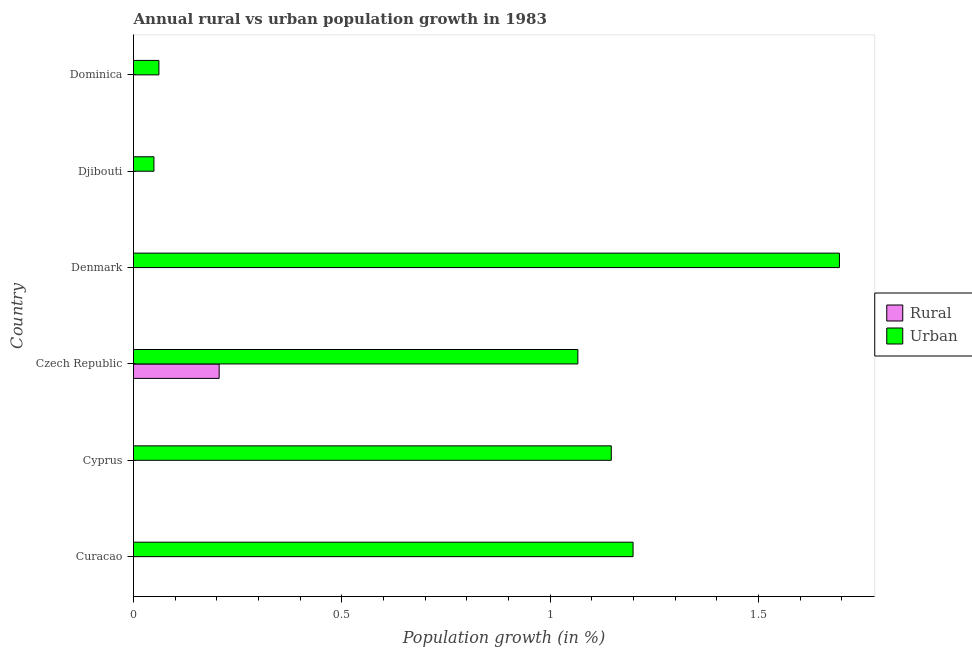Are the number of bars per tick equal to the number of legend labels?
Keep it short and to the point. No. What is the label of the 1st group of bars from the top?
Give a very brief answer. Dominica. In how many cases, is the number of bars for a given country not equal to the number of legend labels?
Your answer should be compact. 5. What is the urban population growth in Denmark?
Provide a succinct answer. 1.69. Across all countries, what is the maximum rural population growth?
Provide a short and direct response. 0.21. Across all countries, what is the minimum urban population growth?
Give a very brief answer. 0.05. What is the total rural population growth in the graph?
Give a very brief answer. 0.21. What is the difference between the urban population growth in Curacao and that in Czech Republic?
Keep it short and to the point. 0.13. What is the difference between the urban population growth in Cyprus and the rural population growth in Djibouti?
Provide a succinct answer. 1.15. What is the average urban population growth per country?
Ensure brevity in your answer.  0.87. What is the difference between the rural population growth and urban population growth in Czech Republic?
Ensure brevity in your answer.  -0.86. What is the ratio of the urban population growth in Curacao to that in Denmark?
Offer a terse response. 0.71. What is the difference between the highest and the second highest urban population growth?
Provide a short and direct response. 0.49. What is the difference between the highest and the lowest rural population growth?
Provide a succinct answer. 0.21. In how many countries, is the urban population growth greater than the average urban population growth taken over all countries?
Provide a succinct answer. 4. Are all the bars in the graph horizontal?
Offer a terse response. Yes. How many countries are there in the graph?
Keep it short and to the point. 6. Where does the legend appear in the graph?
Keep it short and to the point. Center right. What is the title of the graph?
Provide a short and direct response. Annual rural vs urban population growth in 1983. Does "Under-5(male)" appear as one of the legend labels in the graph?
Offer a very short reply. No. What is the label or title of the X-axis?
Your answer should be very brief. Population growth (in %). What is the Population growth (in %) of Urban  in Curacao?
Provide a succinct answer. 1.2. What is the Population growth (in %) of Rural in Cyprus?
Give a very brief answer. 0. What is the Population growth (in %) in Urban  in Cyprus?
Your answer should be compact. 1.15. What is the Population growth (in %) of Rural in Czech Republic?
Offer a very short reply. 0.21. What is the Population growth (in %) of Urban  in Czech Republic?
Your response must be concise. 1.07. What is the Population growth (in %) in Rural in Denmark?
Provide a succinct answer. 0. What is the Population growth (in %) in Urban  in Denmark?
Ensure brevity in your answer.  1.69. What is the Population growth (in %) in Urban  in Djibouti?
Offer a terse response. 0.05. What is the Population growth (in %) of Urban  in Dominica?
Offer a terse response. 0.06. Across all countries, what is the maximum Population growth (in %) in Rural?
Make the answer very short. 0.21. Across all countries, what is the maximum Population growth (in %) in Urban ?
Provide a succinct answer. 1.69. Across all countries, what is the minimum Population growth (in %) of Urban ?
Your response must be concise. 0.05. What is the total Population growth (in %) of Rural in the graph?
Offer a very short reply. 0.21. What is the total Population growth (in %) in Urban  in the graph?
Provide a short and direct response. 5.22. What is the difference between the Population growth (in %) of Urban  in Curacao and that in Cyprus?
Make the answer very short. 0.05. What is the difference between the Population growth (in %) of Urban  in Curacao and that in Czech Republic?
Provide a short and direct response. 0.13. What is the difference between the Population growth (in %) of Urban  in Curacao and that in Denmark?
Make the answer very short. -0.5. What is the difference between the Population growth (in %) of Urban  in Curacao and that in Djibouti?
Ensure brevity in your answer.  1.15. What is the difference between the Population growth (in %) of Urban  in Curacao and that in Dominica?
Keep it short and to the point. 1.14. What is the difference between the Population growth (in %) in Urban  in Cyprus and that in Czech Republic?
Provide a short and direct response. 0.08. What is the difference between the Population growth (in %) in Urban  in Cyprus and that in Denmark?
Provide a succinct answer. -0.55. What is the difference between the Population growth (in %) in Urban  in Cyprus and that in Djibouti?
Your response must be concise. 1.1. What is the difference between the Population growth (in %) in Urban  in Cyprus and that in Dominica?
Keep it short and to the point. 1.09. What is the difference between the Population growth (in %) in Urban  in Czech Republic and that in Denmark?
Your response must be concise. -0.63. What is the difference between the Population growth (in %) in Urban  in Czech Republic and that in Djibouti?
Provide a short and direct response. 1.02. What is the difference between the Population growth (in %) of Urban  in Czech Republic and that in Dominica?
Give a very brief answer. 1.01. What is the difference between the Population growth (in %) in Urban  in Denmark and that in Djibouti?
Your answer should be compact. 1.65. What is the difference between the Population growth (in %) of Urban  in Denmark and that in Dominica?
Keep it short and to the point. 1.63. What is the difference between the Population growth (in %) of Urban  in Djibouti and that in Dominica?
Your answer should be very brief. -0.01. What is the difference between the Population growth (in %) of Rural in Czech Republic and the Population growth (in %) of Urban  in Denmark?
Provide a short and direct response. -1.49. What is the difference between the Population growth (in %) in Rural in Czech Republic and the Population growth (in %) in Urban  in Djibouti?
Give a very brief answer. 0.16. What is the difference between the Population growth (in %) in Rural in Czech Republic and the Population growth (in %) in Urban  in Dominica?
Your answer should be very brief. 0.14. What is the average Population growth (in %) in Rural per country?
Provide a succinct answer. 0.03. What is the average Population growth (in %) in Urban  per country?
Provide a short and direct response. 0.87. What is the difference between the Population growth (in %) in Rural and Population growth (in %) in Urban  in Czech Republic?
Keep it short and to the point. -0.86. What is the ratio of the Population growth (in %) in Urban  in Curacao to that in Cyprus?
Make the answer very short. 1.05. What is the ratio of the Population growth (in %) in Urban  in Curacao to that in Czech Republic?
Make the answer very short. 1.12. What is the ratio of the Population growth (in %) in Urban  in Curacao to that in Denmark?
Make the answer very short. 0.71. What is the ratio of the Population growth (in %) in Urban  in Curacao to that in Djibouti?
Your answer should be very brief. 24.44. What is the ratio of the Population growth (in %) in Urban  in Curacao to that in Dominica?
Give a very brief answer. 19.66. What is the ratio of the Population growth (in %) in Urban  in Cyprus to that in Czech Republic?
Your answer should be very brief. 1.08. What is the ratio of the Population growth (in %) in Urban  in Cyprus to that in Denmark?
Ensure brevity in your answer.  0.68. What is the ratio of the Population growth (in %) in Urban  in Cyprus to that in Djibouti?
Your response must be concise. 23.38. What is the ratio of the Population growth (in %) of Urban  in Cyprus to that in Dominica?
Give a very brief answer. 18.81. What is the ratio of the Population growth (in %) of Urban  in Czech Republic to that in Denmark?
Your answer should be very brief. 0.63. What is the ratio of the Population growth (in %) of Urban  in Czech Republic to that in Djibouti?
Offer a terse response. 21.74. What is the ratio of the Population growth (in %) of Urban  in Czech Republic to that in Dominica?
Offer a terse response. 17.49. What is the ratio of the Population growth (in %) in Urban  in Denmark to that in Djibouti?
Your response must be concise. 34.54. What is the ratio of the Population growth (in %) in Urban  in Denmark to that in Dominica?
Your answer should be compact. 27.79. What is the ratio of the Population growth (in %) of Urban  in Djibouti to that in Dominica?
Keep it short and to the point. 0.8. What is the difference between the highest and the second highest Population growth (in %) of Urban ?
Keep it short and to the point. 0.5. What is the difference between the highest and the lowest Population growth (in %) of Rural?
Offer a very short reply. 0.21. What is the difference between the highest and the lowest Population growth (in %) of Urban ?
Your answer should be compact. 1.65. 